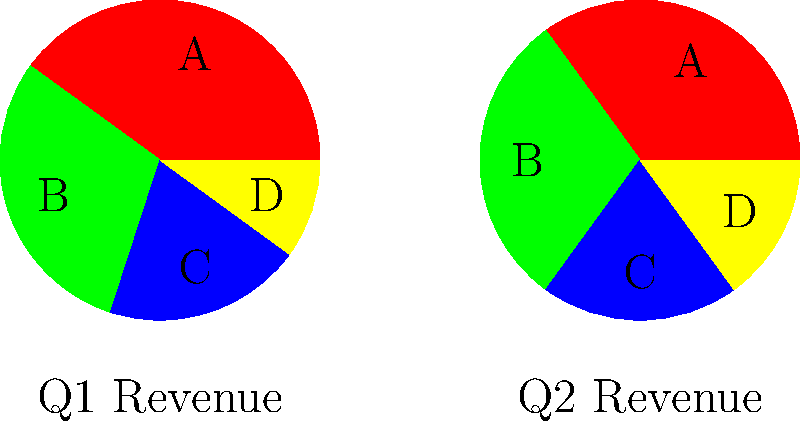Analyze the two pie charts representing revenue streams for Q1 and Q2. Which revenue stream shows the most significant discrepancy between the two quarters, and what is the magnitude of this discrepancy? To identify the most significant discrepancy between revenue streams in Q1 and Q2, we need to compare each segment across both charts:

1. Stream A (Red):
   Q1: 40%, Q2: 35%
   Difference: 5% decrease

2. Stream B (Green):
   Q1: 30%, Q2: 30%
   Difference: 0% (no change)

3. Stream C (Blue):
   Q1: 20%, Q2: 20%
   Difference: 0% (no change)

4. Stream D (Yellow):
   Q1: 10%, Q2: 15%
   Difference: 5% increase

The most significant discrepancies are in streams A and D, both with a 5% change. However, stream A decreased while stream D increased.

To determine which is more significant, we need to consider the relative change:
- Stream A: 5% decrease from 40% is a 12.5% relative decrease (5/40 * 100)
- Stream D: 5% increase from 10% is a 50% relative increase (5/10 * 100)

Therefore, the most significant discrepancy is in stream D, with a 5% absolute increase or a 50% relative increase from Q1 to Q2.
Answer: Stream D, 5% increase (50% relative increase) 